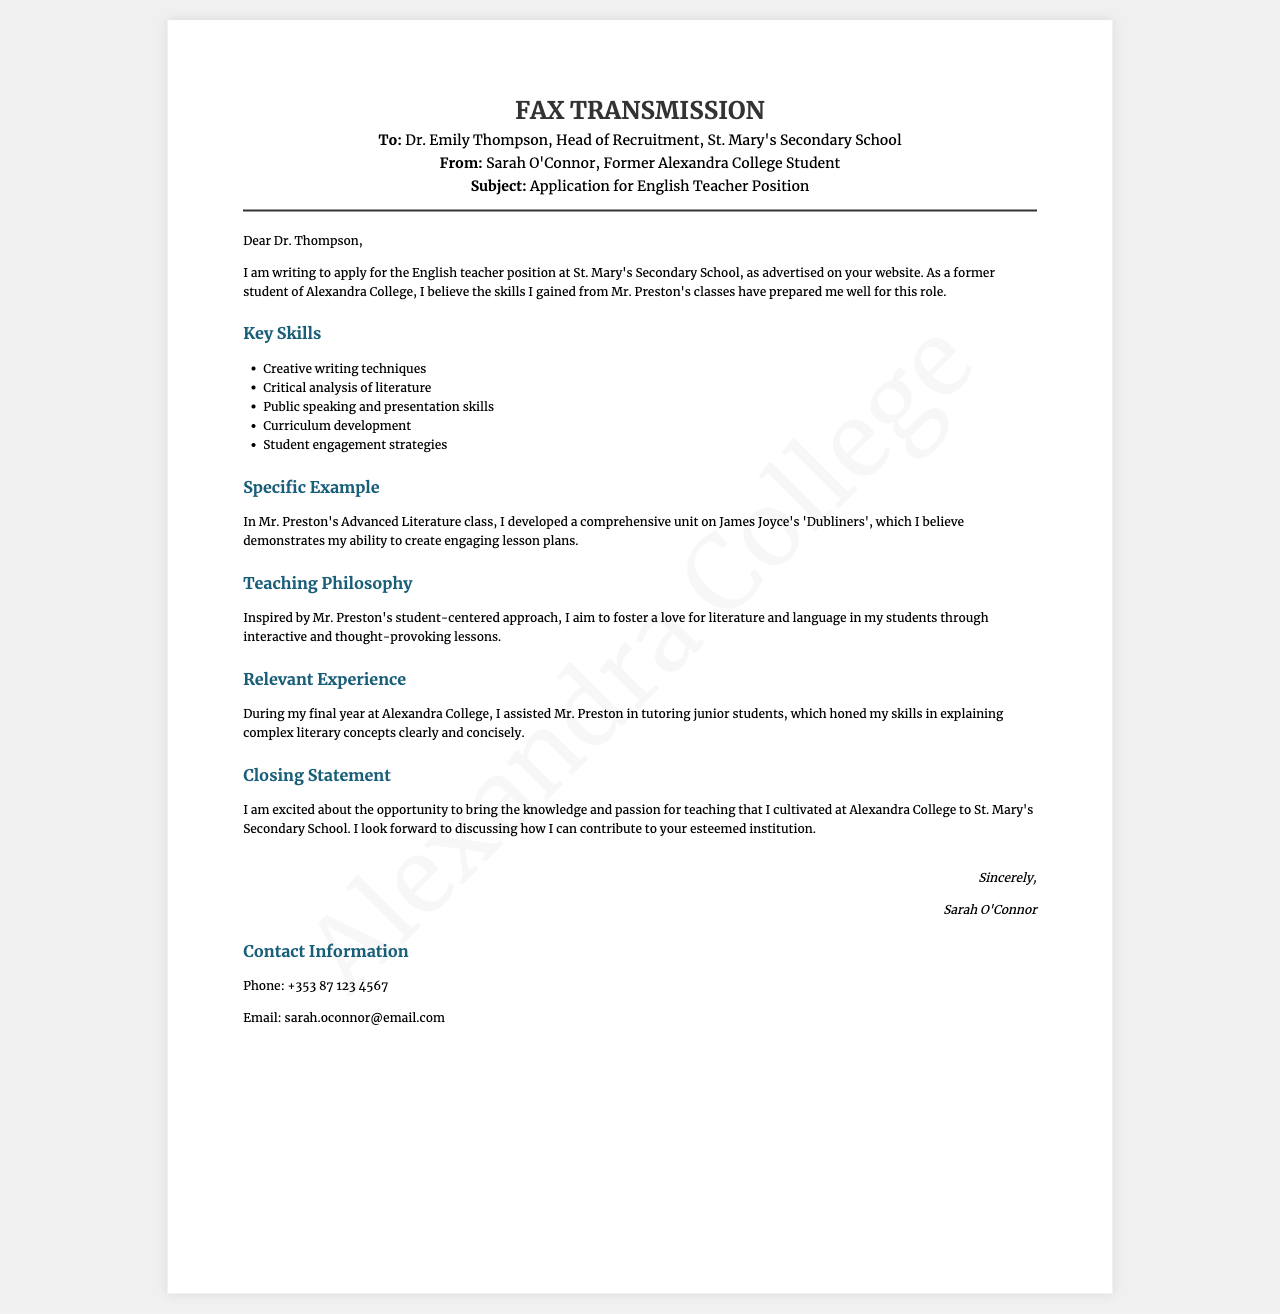What is the title of the fax? The title of the fax is presented prominently at the top of the document.
Answer: Application for English Teacher Position Who is the recipient of the fax? The document specifies the recipient at the top under "To:".
Answer: Dr. Emily Thompson What organization is Sarah O'Connor applying to? The document mentions the organization in the greeting section.
Answer: St. Mary's Secondary School Which specific literary work did Sarah develop a unit on? The document includes a specific example of Sarah's work in the skills section.
Answer: Dubliners What is one of the key skills listed in the application? The document enumerates several key skills that Sarah possesses.
Answer: Public speaking and presentation skills What year did Sarah assist Mr. Preston in tutoring junior students? The document indicates that this experience took place during her final year at Alexandra College.
Answer: Final year What is the main teaching philosophy described in the fax? The document provides insight into Sarah's teaching philosophy under a dedicated section.
Answer: Student-centered approach What type of document is this? The format and header information hint at the category of the document.
Answer: Fax What is Sarah O'Connor's contact phone number? The contact information section lists her phone number clearly.
Answer: +353 87 123 4567 